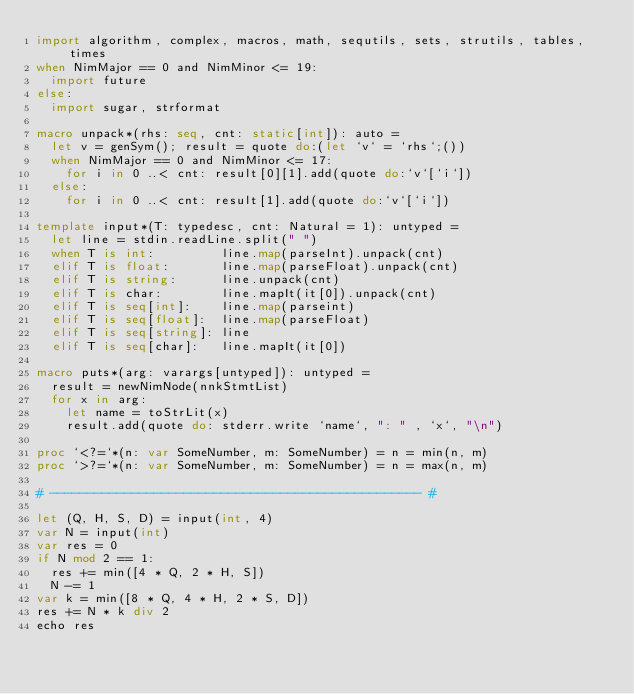Convert code to text. <code><loc_0><loc_0><loc_500><loc_500><_Nim_>import algorithm, complex, macros, math, sequtils, sets, strutils, tables, times
when NimMajor == 0 and NimMinor <= 19:
  import future
else:
  import sugar, strformat

macro unpack*(rhs: seq, cnt: static[int]): auto =
  let v = genSym(); result = quote do:(let `v` = `rhs`;())
  when NimMajor == 0 and NimMinor <= 17:
    for i in 0 ..< cnt: result[0][1].add(quote do:`v`[`i`])
  else:
    for i in 0 ..< cnt: result[1].add(quote do:`v`[`i`])

template input*(T: typedesc, cnt: Natural = 1): untyped =
  let line = stdin.readLine.split(" ")
  when T is int:         line.map(parseInt).unpack(cnt)
  elif T is float:       line.map(parseFloat).unpack(cnt)
  elif T is string:      line.unpack(cnt)
  elif T is char:        line.mapIt(it[0]).unpack(cnt)
  elif T is seq[int]:    line.map(parseint)
  elif T is seq[float]:  line.map(parseFloat)
  elif T is seq[string]: line
  elif T is seq[char]:   line.mapIt(it[0])

macro puts*(arg: varargs[untyped]): untyped =
  result = newNimNode(nnkStmtList)
  for x in arg:
    let name = toStrLit(x)
    result.add(quote do: stderr.write `name`, ": " , `x`, "\n")

proc `<?=`*(n: var SomeNumber, m: SomeNumber) = n = min(n, m)
proc `>?=`*(n: var SomeNumber, m: SomeNumber) = n = max(n, m)

# -------------------------------------------------- #

let (Q, H, S, D) = input(int, 4)
var N = input(int)
var res = 0
if N mod 2 == 1:
  res += min([4 * Q, 2 * H, S])
  N -= 1
var k = min([8 * Q, 4 * H, 2 * S, D])
res += N * k div 2
echo res</code> 